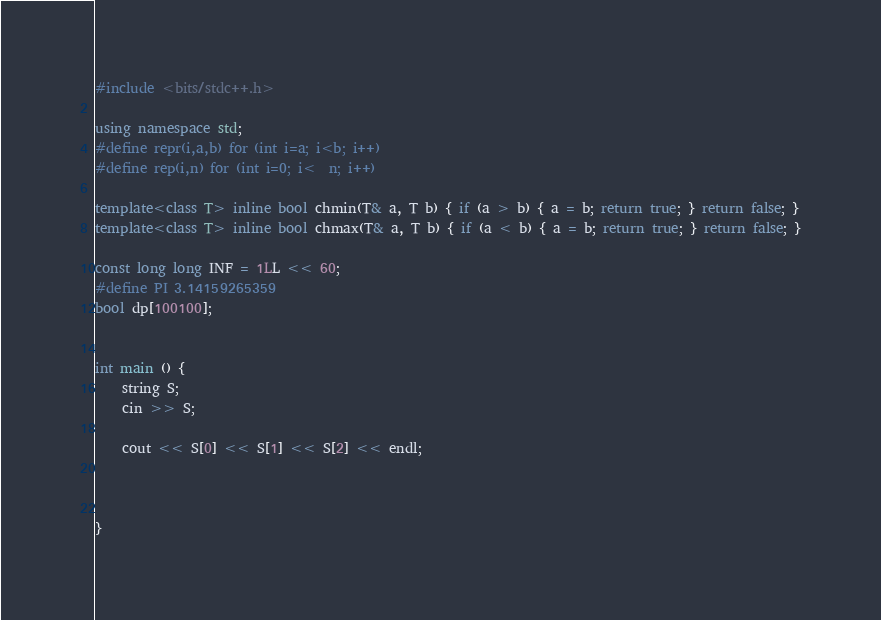Convert code to text. <code><loc_0><loc_0><loc_500><loc_500><_C++_>#include <bits/stdc++.h>
 
using namespace std;
#define repr(i,a,b) for (int i=a; i<b; i++)
#define rep(i,n) for (int i=0; i<  n; i++)
 
template<class T> inline bool chmin(T& a, T b) { if (a > b) { a = b; return true; } return false; }
template<class T> inline bool chmax(T& a, T b) { if (a < b) { a = b; return true; } return false; }
 
const long long INF = 1LL << 60;
#define PI 3.14159265359 
bool dp[100100];
 
 
int main () {
    string S;
    cin >> S;

    cout << S[0] << S[1] << S[2] << endl;

    

}</code> 